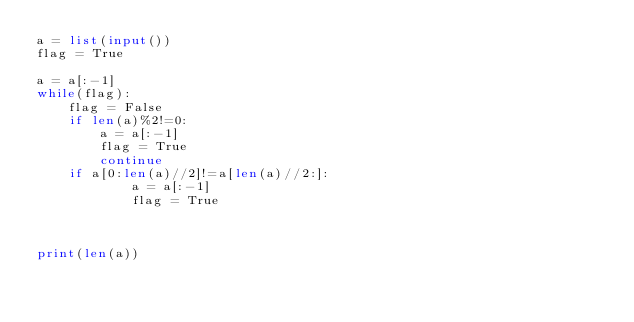<code> <loc_0><loc_0><loc_500><loc_500><_Python_>a = list(input())
flag = True

a = a[:-1]
while(flag):
    flag = False
    if len(a)%2!=0:
        a = a[:-1]
        flag = True
        continue
    if a[0:len(a)//2]!=a[len(a)//2:]:
            a = a[:-1]
            flag = True



print(len(a))</code> 